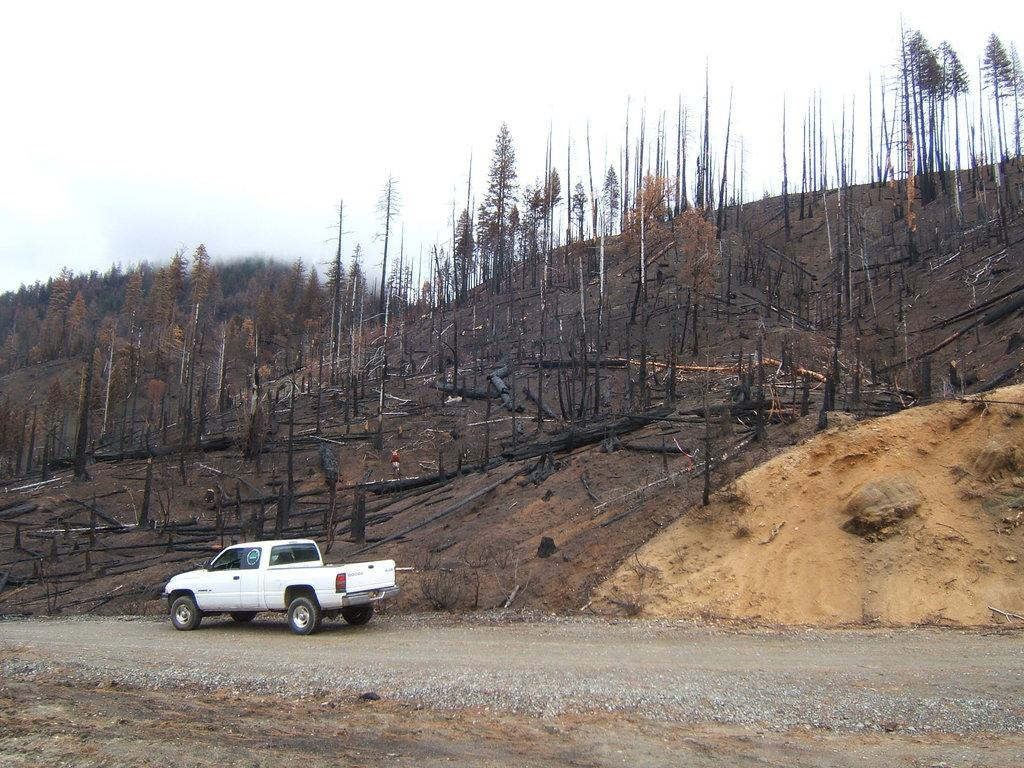What type of vehicle is on the road in the image? There is a white car on the road in the bottom right of the image. What can be seen in the background of the image? There are many trees on a mountain in the background of the image. What is visible at the top of the image? The sky is visible at the top of the image. What can be observed in the sky? Clouds are present in the sky. Where is the farm located in the image? There is no farm present in the image. How does the doll control the car in the image? There is no doll present in the image. 